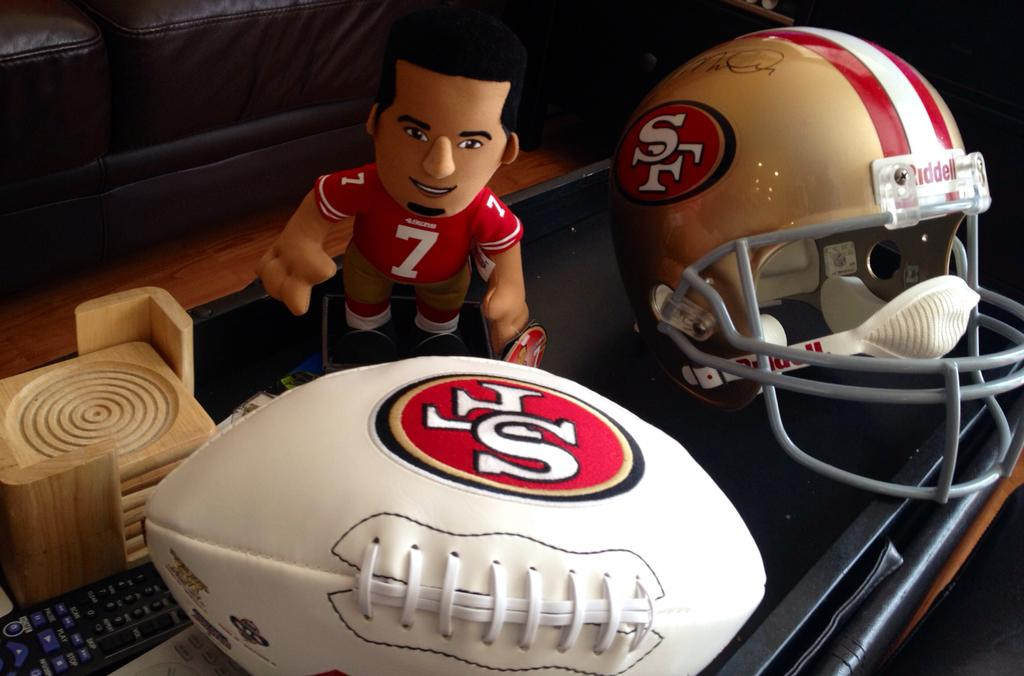What type of toy is present in the image? There is a toy in the image, but the specific type cannot be determined from the provided facts. What protective gear is visible in the image? There is a helmet in the image. What type of sports or play equipment is present in the image? There is a ball in the image. What device is used for controlling electronic devices in the image? There is a remote in the image. What material is used for the wooden object in the image? The wooden object in the image is made of wood. What is the common feature of all the objects in the image? All of these objects are on a platform. What can be seen in the background of the image? There are objects visible in the background of the image, but their specific nature cannot be determined from the provided facts. What type of food is being prepared in the image? There is no food present in the image; it features a toy, helmet, ball, remote, wooden object, and background objects on a platform. How many cats are visible in the image? There are no cats present in the image. 